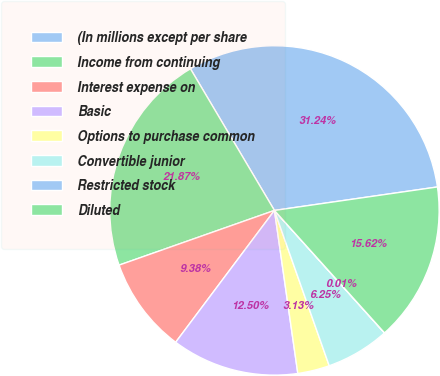Convert chart. <chart><loc_0><loc_0><loc_500><loc_500><pie_chart><fcel>(In millions except per share<fcel>Income from continuing<fcel>Interest expense on<fcel>Basic<fcel>Options to purchase common<fcel>Convertible junior<fcel>Restricted stock<fcel>Diluted<nl><fcel>31.24%<fcel>21.87%<fcel>9.38%<fcel>12.5%<fcel>3.13%<fcel>6.25%<fcel>0.01%<fcel>15.62%<nl></chart> 